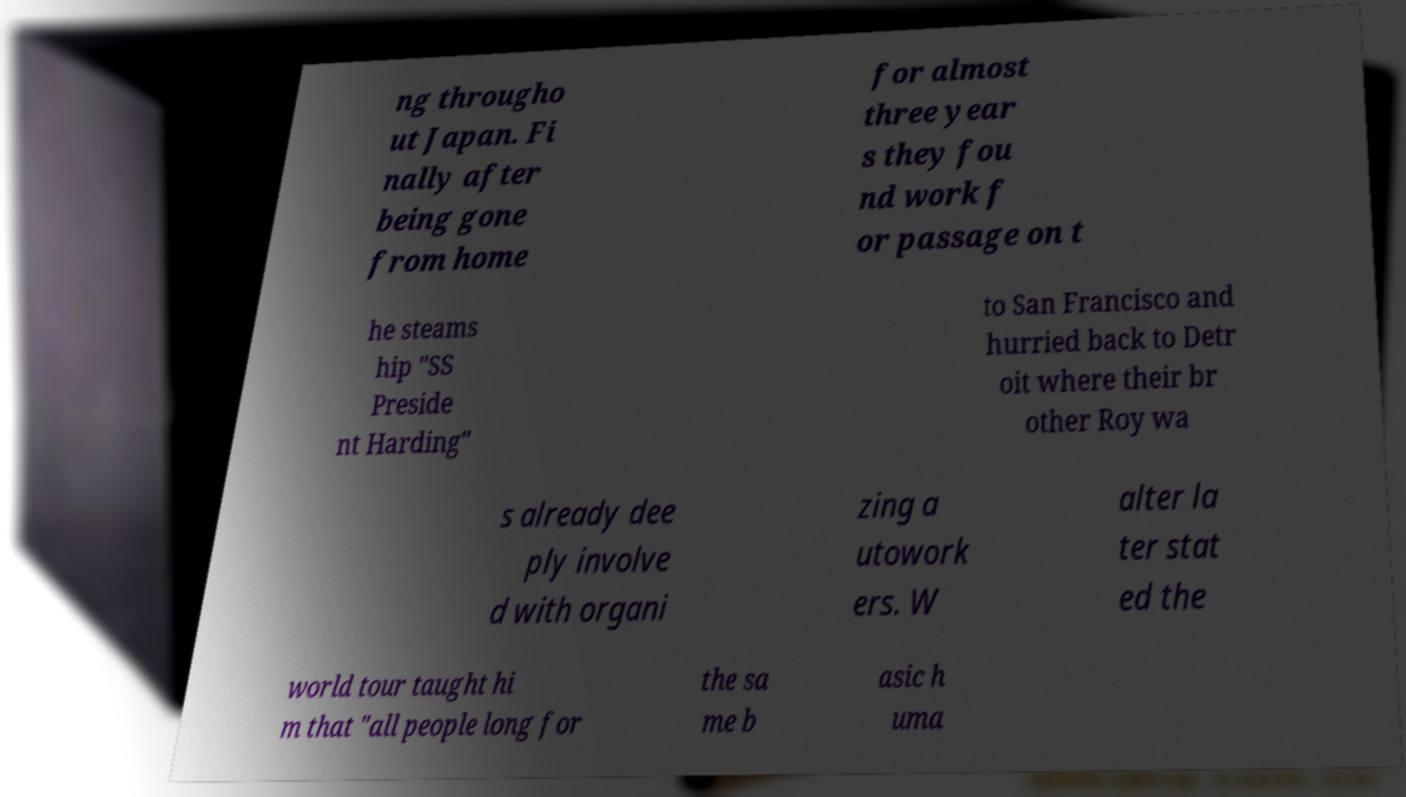Could you extract and type out the text from this image? ng througho ut Japan. Fi nally after being gone from home for almost three year s they fou nd work f or passage on t he steams hip "SS Preside nt Harding" to San Francisco and hurried back to Detr oit where their br other Roy wa s already dee ply involve d with organi zing a utowork ers. W alter la ter stat ed the world tour taught hi m that "all people long for the sa me b asic h uma 